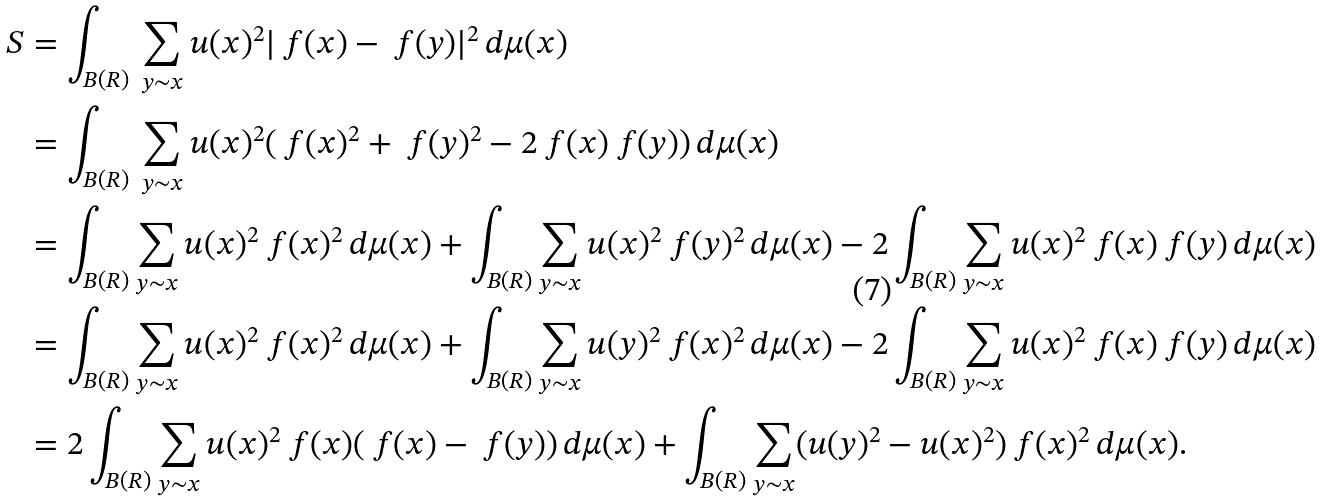<formula> <loc_0><loc_0><loc_500><loc_500>S & = \int _ { B ( R ) } \, \sum _ { y \sim x } u ( x ) ^ { 2 } | \ f ( x ) - \ f ( y ) | ^ { 2 } \, d \mu ( x ) \\ & = \int _ { B ( R ) } \, \sum _ { y \sim x } u ( x ) ^ { 2 } ( \ f ( x ) ^ { 2 } + \ f ( y ) ^ { 2 } - 2 \ f ( x ) \ f ( y ) ) \, d \mu ( x ) \\ & = \int _ { B ( R ) } \sum _ { y \sim x } u ( x ) ^ { 2 } \ f ( x ) ^ { 2 } \, d \mu ( x ) + \int _ { B ( R ) } \sum _ { y \sim x } u ( x ) ^ { 2 } \ f ( y ) ^ { 2 } \, d \mu ( x ) - 2 \int _ { B ( R ) } \sum _ { y \sim x } u ( x ) ^ { 2 } \ f ( x ) \ f ( y ) \, d \mu ( x ) \\ & = \int _ { B ( R ) } \sum _ { y \sim x } u ( x ) ^ { 2 } \ f ( x ) ^ { 2 } \, d \mu ( x ) + \int _ { B ( R ) } \sum _ { y \sim x } u ( y ) ^ { 2 } \ f ( x ) ^ { 2 } \, d \mu ( x ) - 2 \int _ { B ( R ) } \sum _ { y \sim x } u ( x ) ^ { 2 } \ f ( x ) \ f ( y ) \, d \mu ( x ) \\ & = 2 \int _ { B ( R ) } \sum _ { y \sim x } u ( x ) ^ { 2 } \ f ( x ) ( \ f ( x ) - \ f ( y ) ) \, d \mu ( x ) + \int _ { B ( R ) } \sum _ { y \sim x } ( u ( y ) ^ { 2 } - u ( x ) ^ { 2 } ) \ f ( x ) ^ { 2 } \, d \mu ( x ) .</formula> 